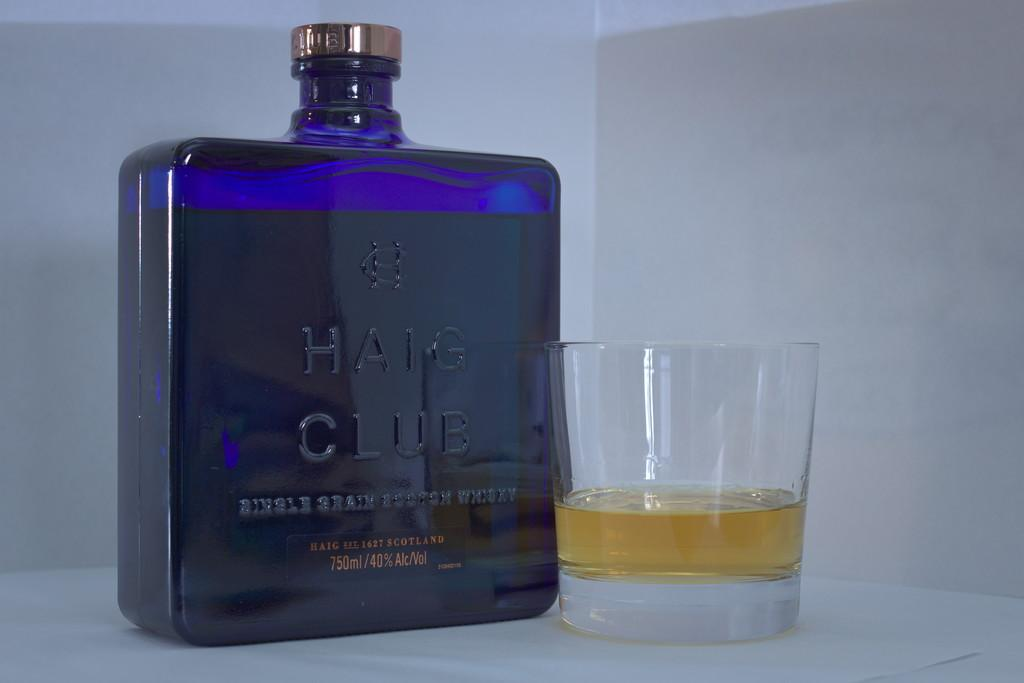What is on the table in the image? There is a glass with a liquid and a blue bottle labeled "Haig Club" on the table. Can you describe the bottle in the image? The bottle is blue and labeled "Haig Club". What color is the background behind the bottle and glass? The background behind the bottle and glass is white. Where is the loaf of bread located in the image? There is no loaf of bread present in the image. Can you tell me how many volcanoes are visible in the image? There are no volcanoes visible in the image. 